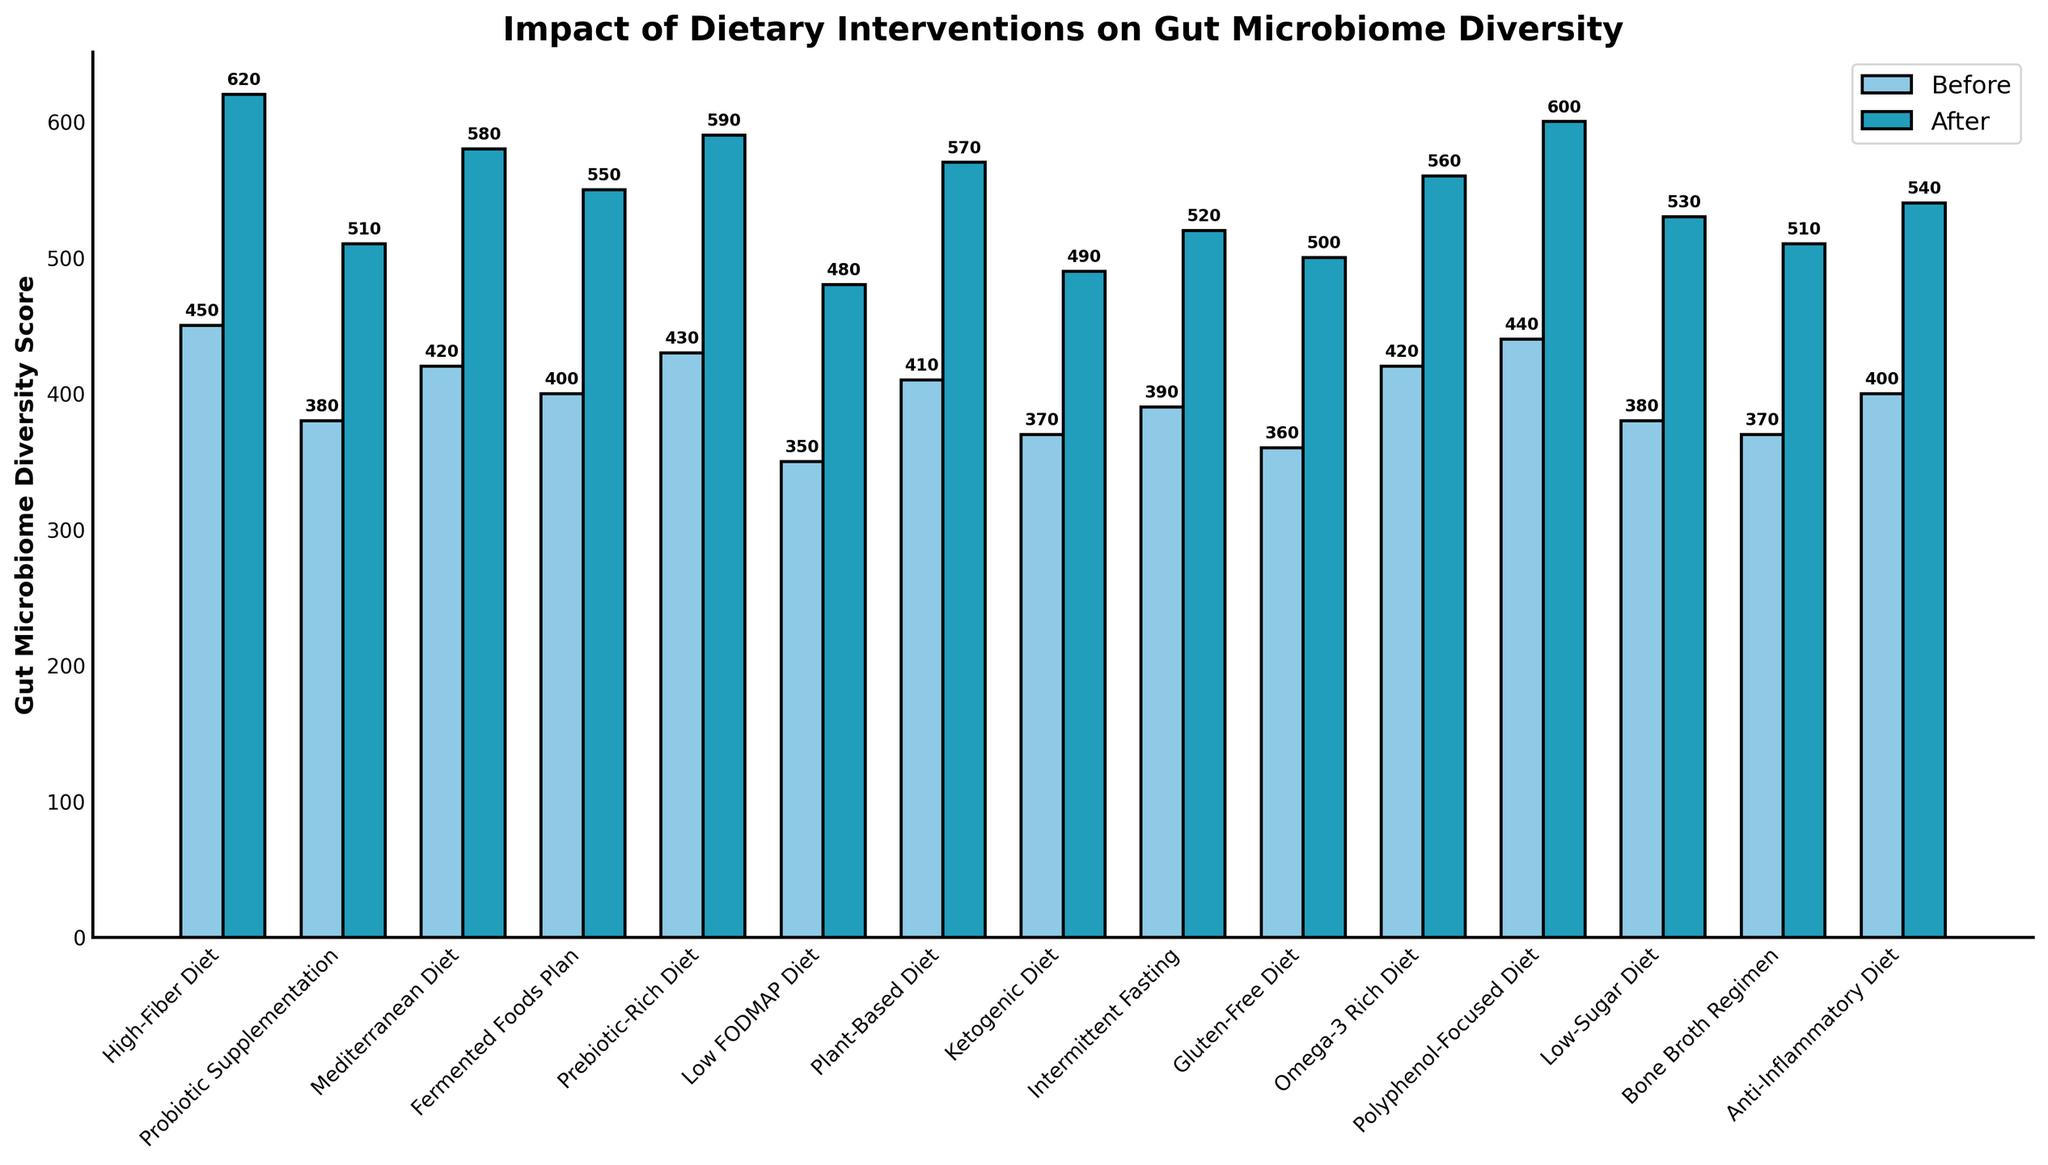What dietary intervention resulted in the highest increase in gut microbiome diversity score? To determine the dietary intervention with the highest increase, subtract the "Before Score" from the "After Score" for each intervention. The one with the highest difference has the highest increase. By calculation, "High-Fiber Diet" resulted in the highest increase (620 - 450 = 170).
Answer: High-Fiber Diet Which dietary intervention had the lowest "Before Score"? Review the "Before Score" values across all interventions and identify the lowest value. The "Low FODMAP Diet" had the lowest "Before Score" at 350.
Answer: Low FODMAP Diet What is the total gut microbiome diversity score after the "Intermittent Fasting" and "Ketogenic Diet" interventions combined? Sum the "After Scores" for "Intermittent Fasting" (520) and "Ketogenic Diet" (490). The total is 520 + 490 = 1010.
Answer: 1010 How many dietary interventions improved the gut microbiome diversity score by more than 100 points? Calculate the difference between the "Before Score" and "After Score" for each intervention. Count how many of these differences are greater than 100. Interventions with differences greater than 100 are "High-Fiber Diet" (170), "Probiotic Supplementation" (130), "Mediterranean Diet" (160), "Prebiotic-Rich Diet" (160), and "Polyphenol-Focused Diet" (160). There are 5 in total.
Answer: 5 What is the average "After Score" for the "Anti-Inflammatory Diet," "Bone Broth Regimen," and "Low-Sugar Diet"? To find the average "After Score," sum the "After Scores" and divide by the number of interventions. The sum is 540 (Anti-Inflammatory Diet) + 510 (Bone Broth Regimen) + 530 (Low-Sugar Diet) = 1580. The average is 1580 / 3 = 526.67.
Answer: 526.67 Which dietary intervention showed a greater improvement: "Fermented Foods Plan" or "Prebiotic-Rich Diet"? Subtract the "Before Score" from the "After Score" for both interventions. For "Fermented Foods Plan," the improvement is 550 - 400 = 150. For "Prebiotic-Rich Diet," the improvement is 590 - 430 = 160. "Prebiotic-Rich Diet" showed a greater improvement.
Answer: Prebiotic-Rich Diet Which dietary interventions had an "After Score" below 500? Identify interventions with "After Scores" below 500. These are "Low FODMAP Diet" (480), "Ketogenic Diet" (490), and "Gluten-Free Diet" (500). None of these meet the criteria, as all scores are 500 or above.
Answer: None What was the difference in the "Before Score" between the "Plant-Based Diet" and the "Omega-3 Rich Diet"? Subtract the "Before Score" of the "Omega-3 Rich Diet" from the "Before Score" of the "Plant-Based Diet." The scores are 410 for "Plant-Based Diet" and 420 for "Omega-3 Rich Diet," so the difference is 410 - 420 = -10.
Answer: -10 Which had a higher final score: "Mediterranean Diet" or "Polyphenol-Focused Diet"? Compare the "After Scores" of "Mediterranean Diet" (580) and "Polyphenol-Focused Diet" (600). "Polyphenol-Focused Diet" has a higher final score.
Answer: Polyphenol-Focused Diet 